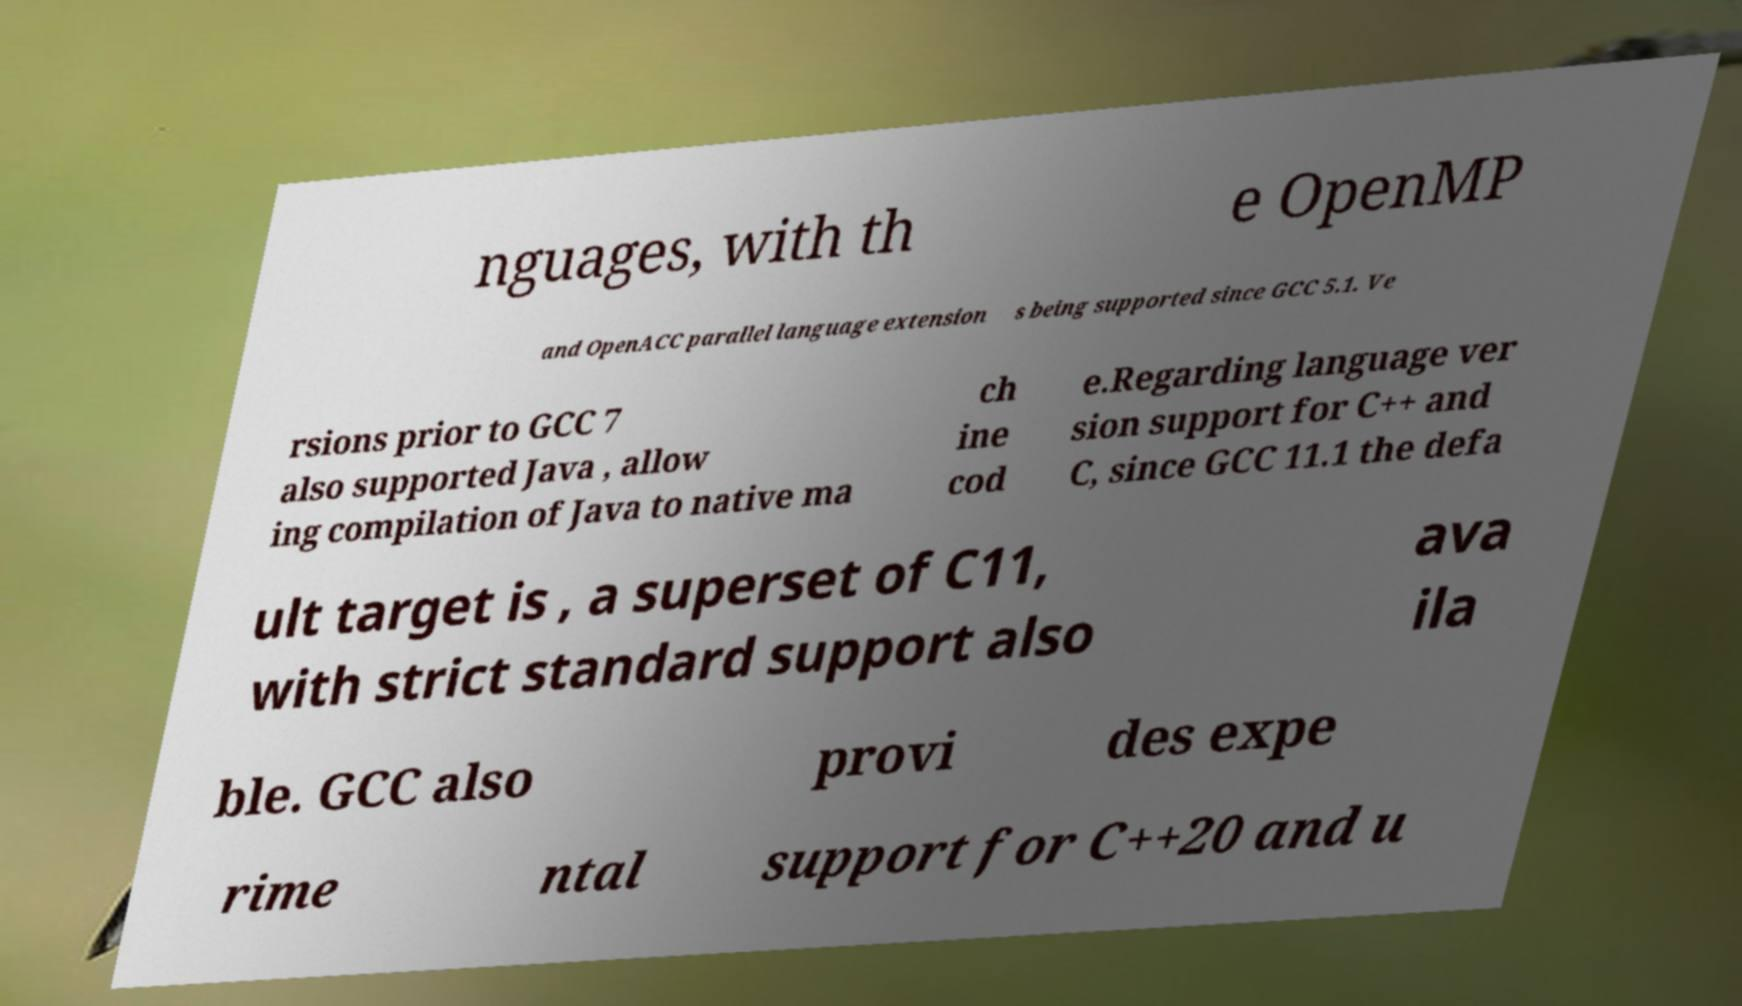There's text embedded in this image that I need extracted. Can you transcribe it verbatim? nguages, with th e OpenMP and OpenACC parallel language extension s being supported since GCC 5.1. Ve rsions prior to GCC 7 also supported Java , allow ing compilation of Java to native ma ch ine cod e.Regarding language ver sion support for C++ and C, since GCC 11.1 the defa ult target is , a superset of C11, with strict standard support also ava ila ble. GCC also provi des expe rime ntal support for C++20 and u 